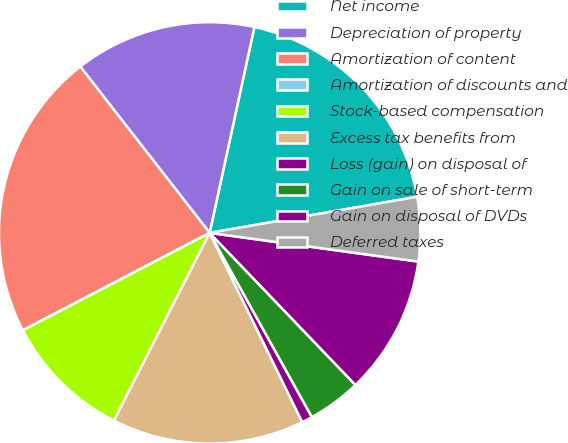Convert chart to OTSL. <chart><loc_0><loc_0><loc_500><loc_500><pie_chart><fcel>Net income<fcel>Depreciation of property<fcel>Amortization of content<fcel>Amortization of discounts and<fcel>Stock-based compensation<fcel>Excess tax benefits from<fcel>Loss (gain) on disposal of<fcel>Gain on sale of short-term<fcel>Gain on disposal of DVDs<fcel>Deferred taxes<nl><fcel>18.85%<fcel>13.93%<fcel>22.13%<fcel>0.0%<fcel>9.84%<fcel>14.75%<fcel>0.82%<fcel>4.1%<fcel>10.66%<fcel>4.92%<nl></chart> 